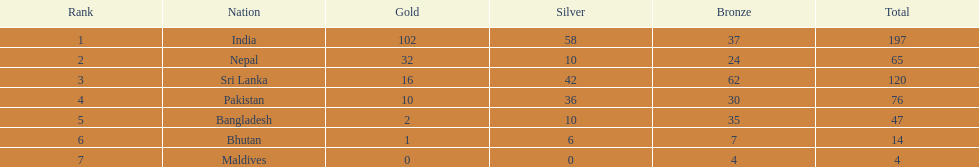Which nation has secured no silver medals? Maldives. 